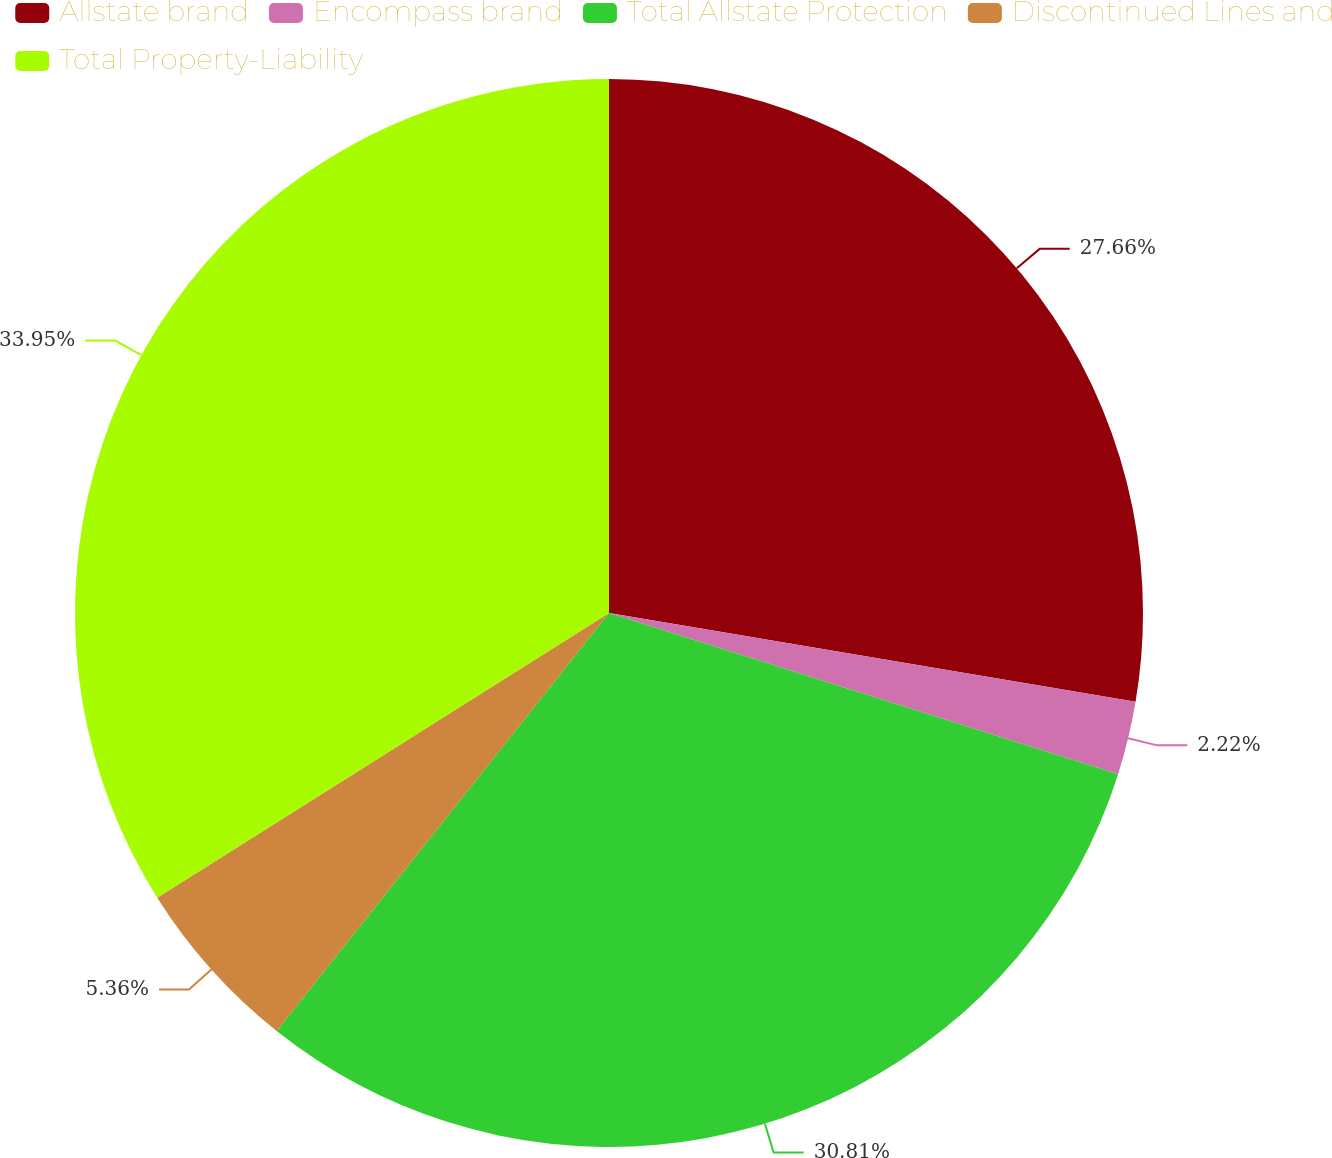Convert chart. <chart><loc_0><loc_0><loc_500><loc_500><pie_chart><fcel>Allstate brand<fcel>Encompass brand<fcel>Total Allstate Protection<fcel>Discontinued Lines and<fcel>Total Property-Liability<nl><fcel>27.66%<fcel>2.22%<fcel>30.81%<fcel>5.36%<fcel>33.95%<nl></chart> 